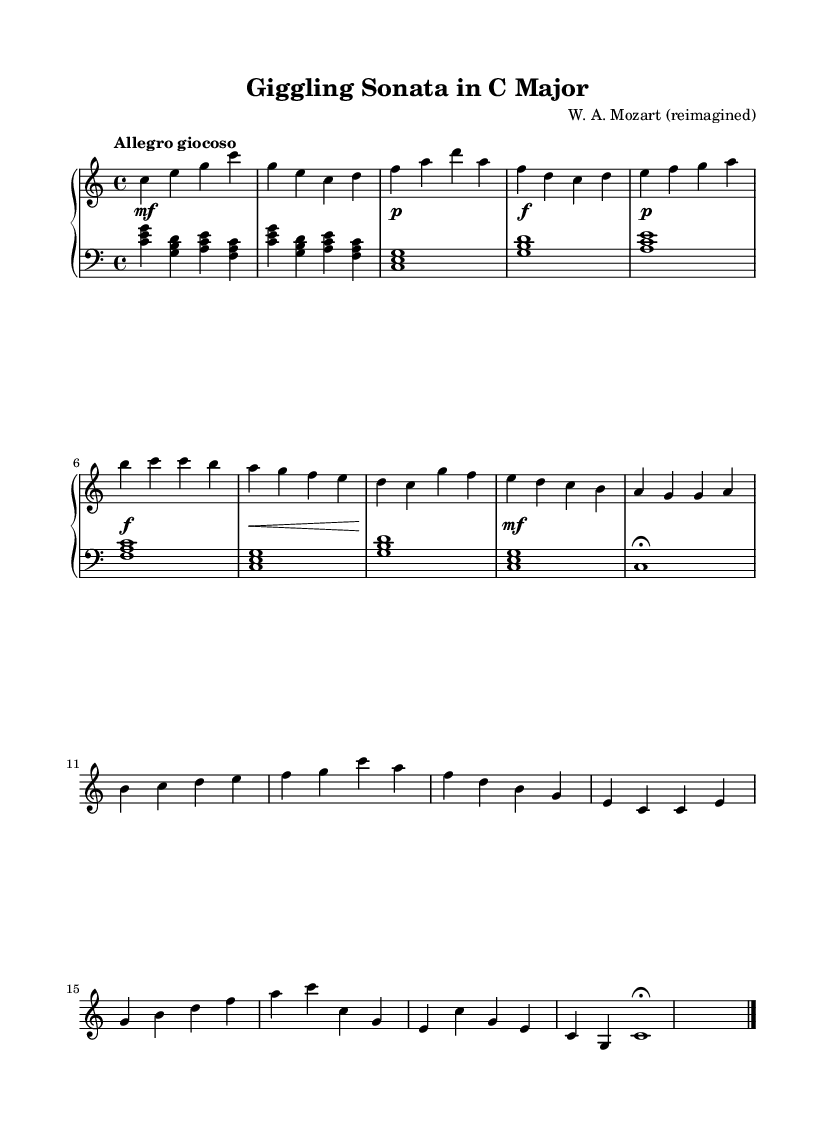What is the key signature of this music? The key signature is C major, which has no sharps or flats indicated at the beginning of the staff.
Answer: C major What is the time signature of the piece? The time signature is displayed at the beginning of the staff as 4/4, which indicates four beats per measure.
Answer: 4/4 What is the tempo marking for this composition? The tempo marking is "Allegro giocoso," which suggests a lively and playful speed for the piece.
Answer: Allegro giocoso How many measures are in the introduction section? The introduction section contains 2 measures, which can be counted by looking at the staff and observing the grouping of notes with barlines.
Answer: 2 What is the dynamic marking at the beginning of the first section? The dynamic marking at the beginning is "mf," which indicates a moderately loud volume for the piece.
Answer: mf What is the final chord of the piece? The final chord is indicated as "c1\fermata," meaning a singular "C" chord that is held longer than usual due to the fermata symbol.
Answer: C 